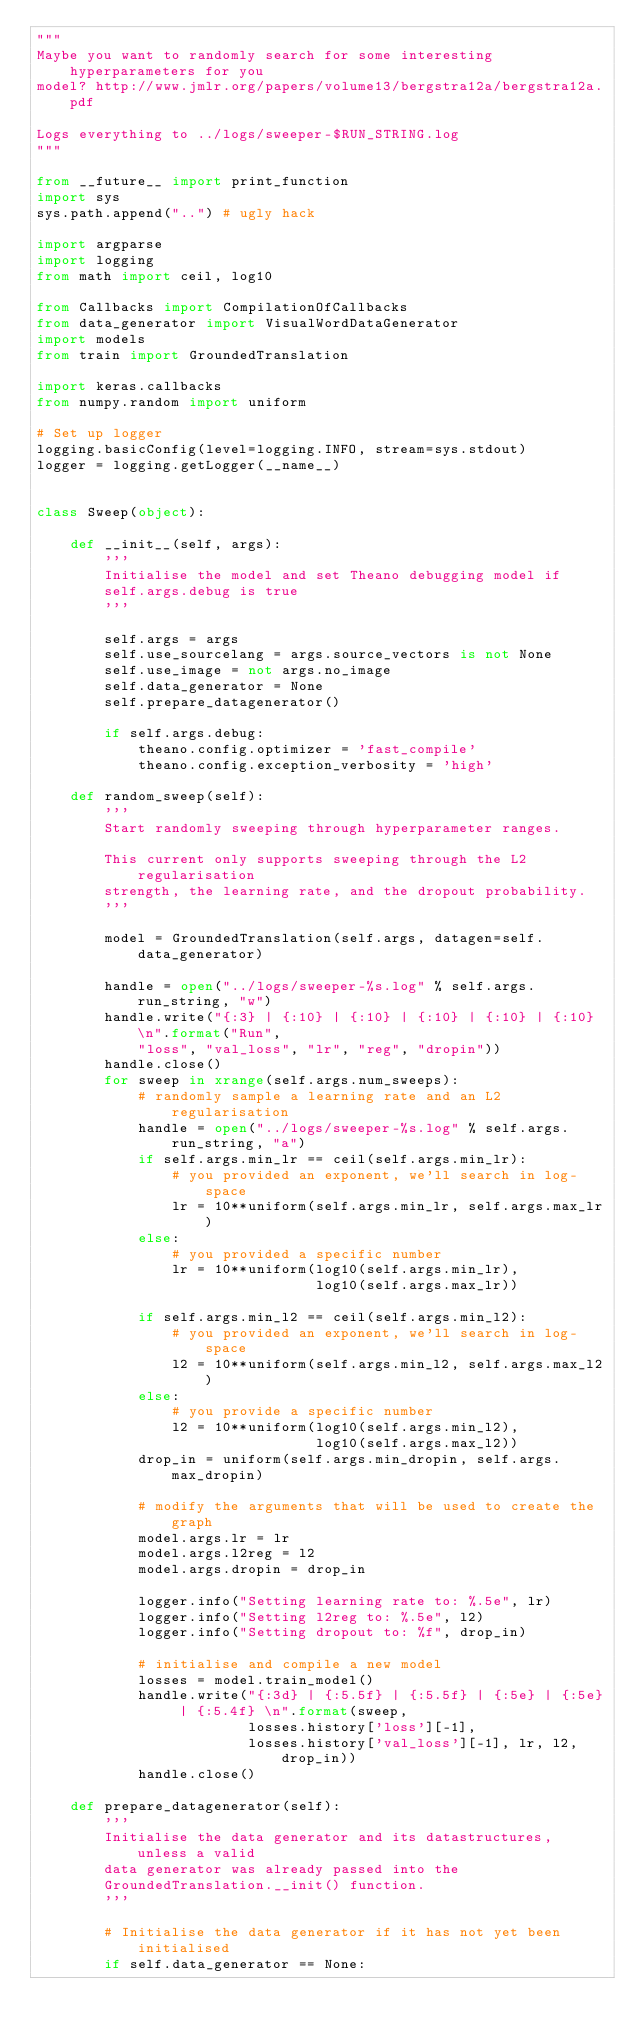Convert code to text. <code><loc_0><loc_0><loc_500><loc_500><_Python_>"""
Maybe you want to randomly search for some interesting hyperparameters for you
model? http://www.jmlr.org/papers/volume13/bergstra12a/bergstra12a.pdf

Logs everything to ../logs/sweeper-$RUN_STRING.log
"""

from __future__ import print_function
import sys
sys.path.append("..") # ugly hack

import argparse
import logging
from math import ceil, log10

from Callbacks import CompilationOfCallbacks
from data_generator import VisualWordDataGenerator
import models
from train import GroundedTranslation

import keras.callbacks
from numpy.random import uniform

# Set up logger
logging.basicConfig(level=logging.INFO, stream=sys.stdout)
logger = logging.getLogger(__name__)


class Sweep(object):

    def __init__(self, args):
        '''
        Initialise the model and set Theano debugging model if
        self.args.debug is true
        '''

        self.args = args
        self.use_sourcelang = args.source_vectors is not None
        self.use_image = not args.no_image
        self.data_generator = None
        self.prepare_datagenerator()

        if self.args.debug:
            theano.config.optimizer = 'fast_compile'
            theano.config.exception_verbosity = 'high'

    def random_sweep(self):
        '''
        Start randomly sweeping through hyperparameter ranges.

        This current only supports sweeping through the L2 regularisation
        strength, the learning rate, and the dropout probability.
        '''

        model = GroundedTranslation(self.args, datagen=self.data_generator)

        handle = open("../logs/sweeper-%s.log" % self.args.run_string, "w")
        handle.write("{:3} | {:10} | {:10} | {:10} | {:10} | {:10} \n".format("Run",
            "loss", "val_loss", "lr", "reg", "dropin"))
        handle.close()
        for sweep in xrange(self.args.num_sweeps):
            # randomly sample a learning rate and an L2 regularisation
            handle = open("../logs/sweeper-%s.log" % self.args.run_string, "a")
            if self.args.min_lr == ceil(self.args.min_lr):
                # you provided an exponent, we'll search in log-space
                lr = 10**uniform(self.args.min_lr, self.args.max_lr)
            else:
                # you provided a specific number
                lr = 10**uniform(log10(self.args.min_lr),
                                 log10(self.args.max_lr))

            if self.args.min_l2 == ceil(self.args.min_l2):
                # you provided an exponent, we'll search in log-space
                l2 = 10**uniform(self.args.min_l2, self.args.max_l2)
            else:
                # you provide a specific number
                l2 = 10**uniform(log10(self.args.min_l2),
                                 log10(self.args.max_l2))
            drop_in = uniform(self.args.min_dropin, self.args.max_dropin)

            # modify the arguments that will be used to create the graph
            model.args.lr = lr
            model.args.l2reg = l2
            model.args.dropin = drop_in

            logger.info("Setting learning rate to: %.5e", lr)
            logger.info("Setting l2reg to: %.5e", l2)
            logger.info("Setting dropout to: %f", drop_in)

            # initialise and compile a new model
            losses = model.train_model()
            handle.write("{:3d} | {:5.5f} | {:5.5f} | {:5e} | {:5e} | {:5.4f} \n".format(sweep,
                         losses.history['loss'][-1],
                         losses.history['val_loss'][-1], lr, l2, drop_in))
            handle.close()

    def prepare_datagenerator(self):
        '''
        Initialise the data generator and its datastructures, unless a valid
        data generator was already passed into the
        GroundedTranslation.__init() function.
        '''

        # Initialise the data generator if it has not yet been initialised
        if self.data_generator == None:</code> 